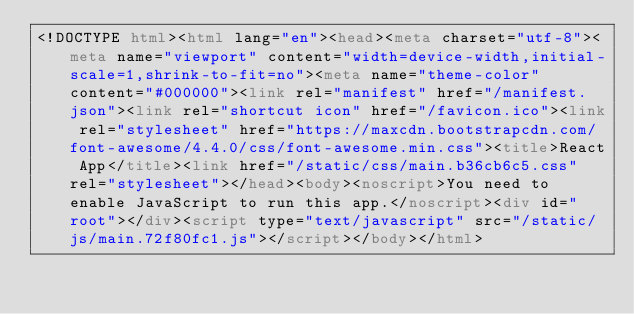Convert code to text. <code><loc_0><loc_0><loc_500><loc_500><_HTML_><!DOCTYPE html><html lang="en"><head><meta charset="utf-8"><meta name="viewport" content="width=device-width,initial-scale=1,shrink-to-fit=no"><meta name="theme-color" content="#000000"><link rel="manifest" href="/manifest.json"><link rel="shortcut icon" href="/favicon.ico"><link rel="stylesheet" href="https://maxcdn.bootstrapcdn.com/font-awesome/4.4.0/css/font-awesome.min.css"><title>React App</title><link href="/static/css/main.b36cb6c5.css" rel="stylesheet"></head><body><noscript>You need to enable JavaScript to run this app.</noscript><div id="root"></div><script type="text/javascript" src="/static/js/main.72f80fc1.js"></script></body></html></code> 